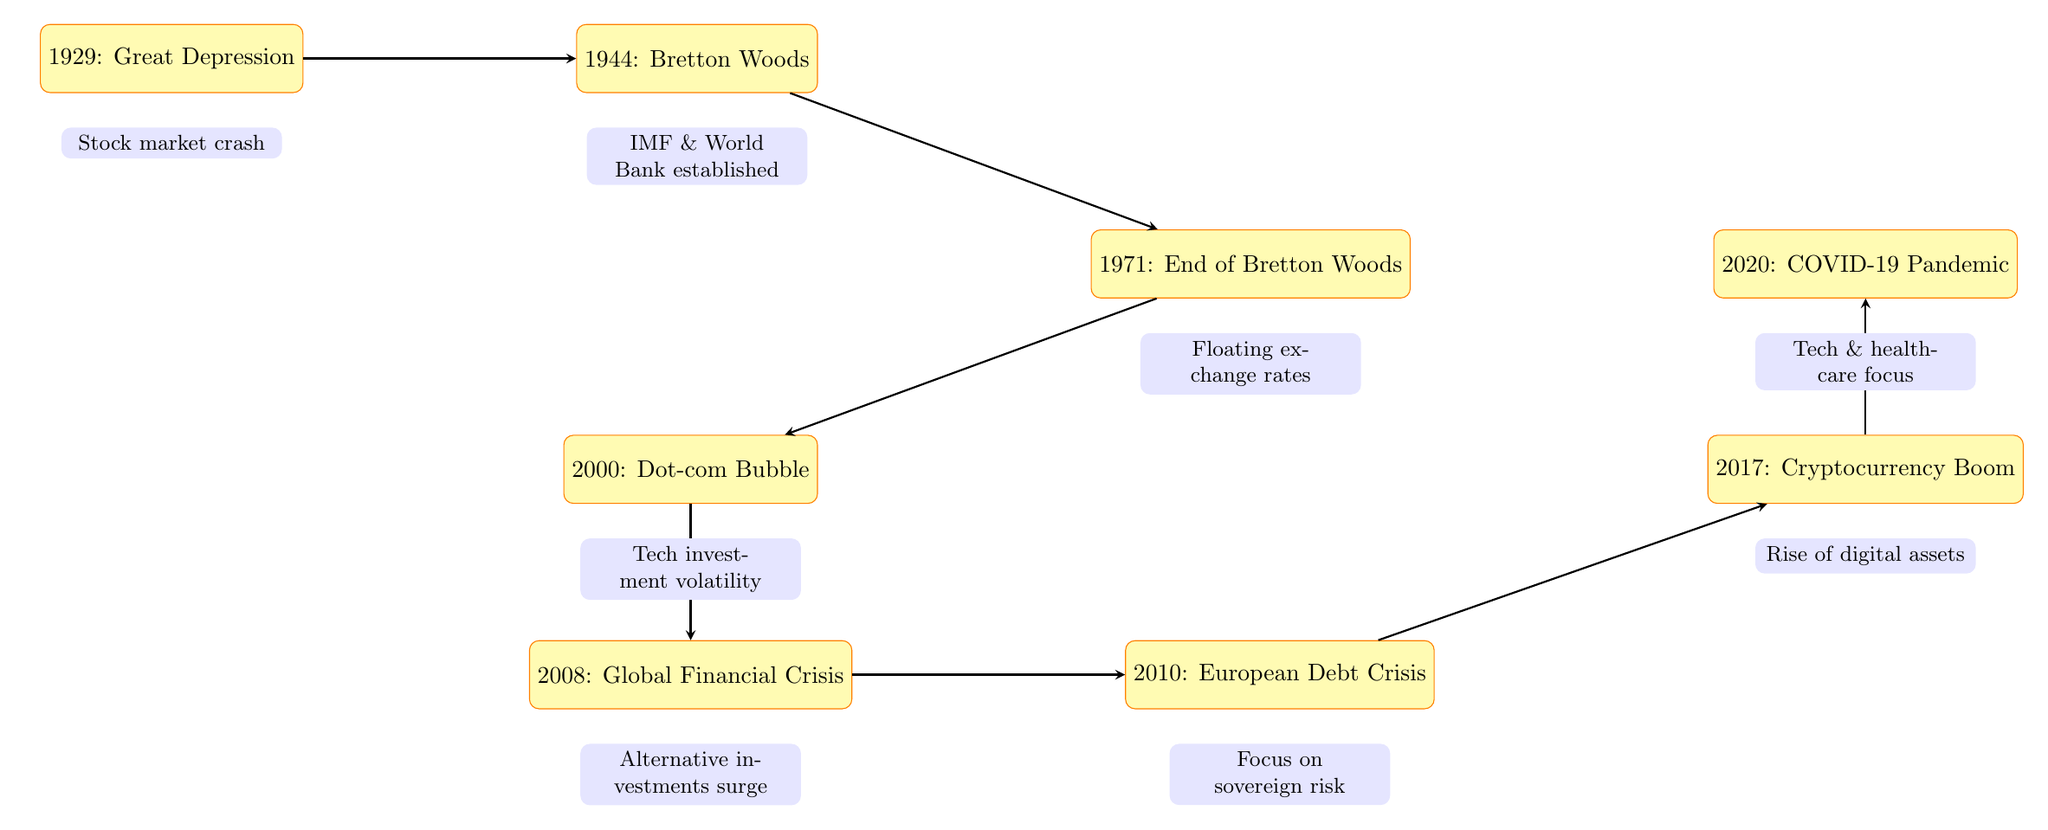What is the first event listed in the timeline? The diagram starts with the event labeled "1929: Great Depression." This is the first node in the flow chart.
Answer: 1929: Great Depression How many key economic events are depicted in the diagram? By counting the event nodes in the flow chart, there are a total of eight events represented from 1929 to 2020.
Answer: 8 What impact did the Global Financial Crisis in 2008 lead to? Looking at the flow from the 2008 node, it states the impact as "surge in alternative investments like commodities and real estate." This indicates the change that occurred after this event.
Answer: Surge in alternative investments like commodities and real estate Which event follows the End of Bretton Woods in the timeline? The diagram indicates a flow from the node labeled "1971: End of Bretton Woods" to "2000: Dot-com Bubble," meaning the Dot-com Bubble follows this event.
Answer: 2000: Dot-com Bubble What significant legislative change occurred as a result of the Great Depression? The arrow from the "1929: Great Depression" node leads to the impact mentioned, which states that it resulted in "long-term changes in investment regulations." This relationship signifies the legislative changes brought about by the event.
Answer: Long-term changes in investment regulations What was established in 1944 as a result of the Bretton Woods Agreement? The flow from the "1944: Bretton Woods" node mentions the establishment of the "IMF and World Bank," indicating what came out of the Bretton Woods Agreement.
Answer: IMF and World Bank How did the COVID-19 pandemic affect investment sectors according to the diagram? Following the "2020: COVID-19 Pandemic" node, the impact listed is a "shift in investment towards technology and healthcare sectors." This indicates the sectors that experienced a focus due to the pandemic.
Answer: Shift in investment towards technology and healthcare sectors In which year did the Cryptocurrency Boom occur? The diagram directly labels the event as occurring in "2017" with the heading "Cryptocurrency Boom." This is the year associated with that event.
Answer: 2017 